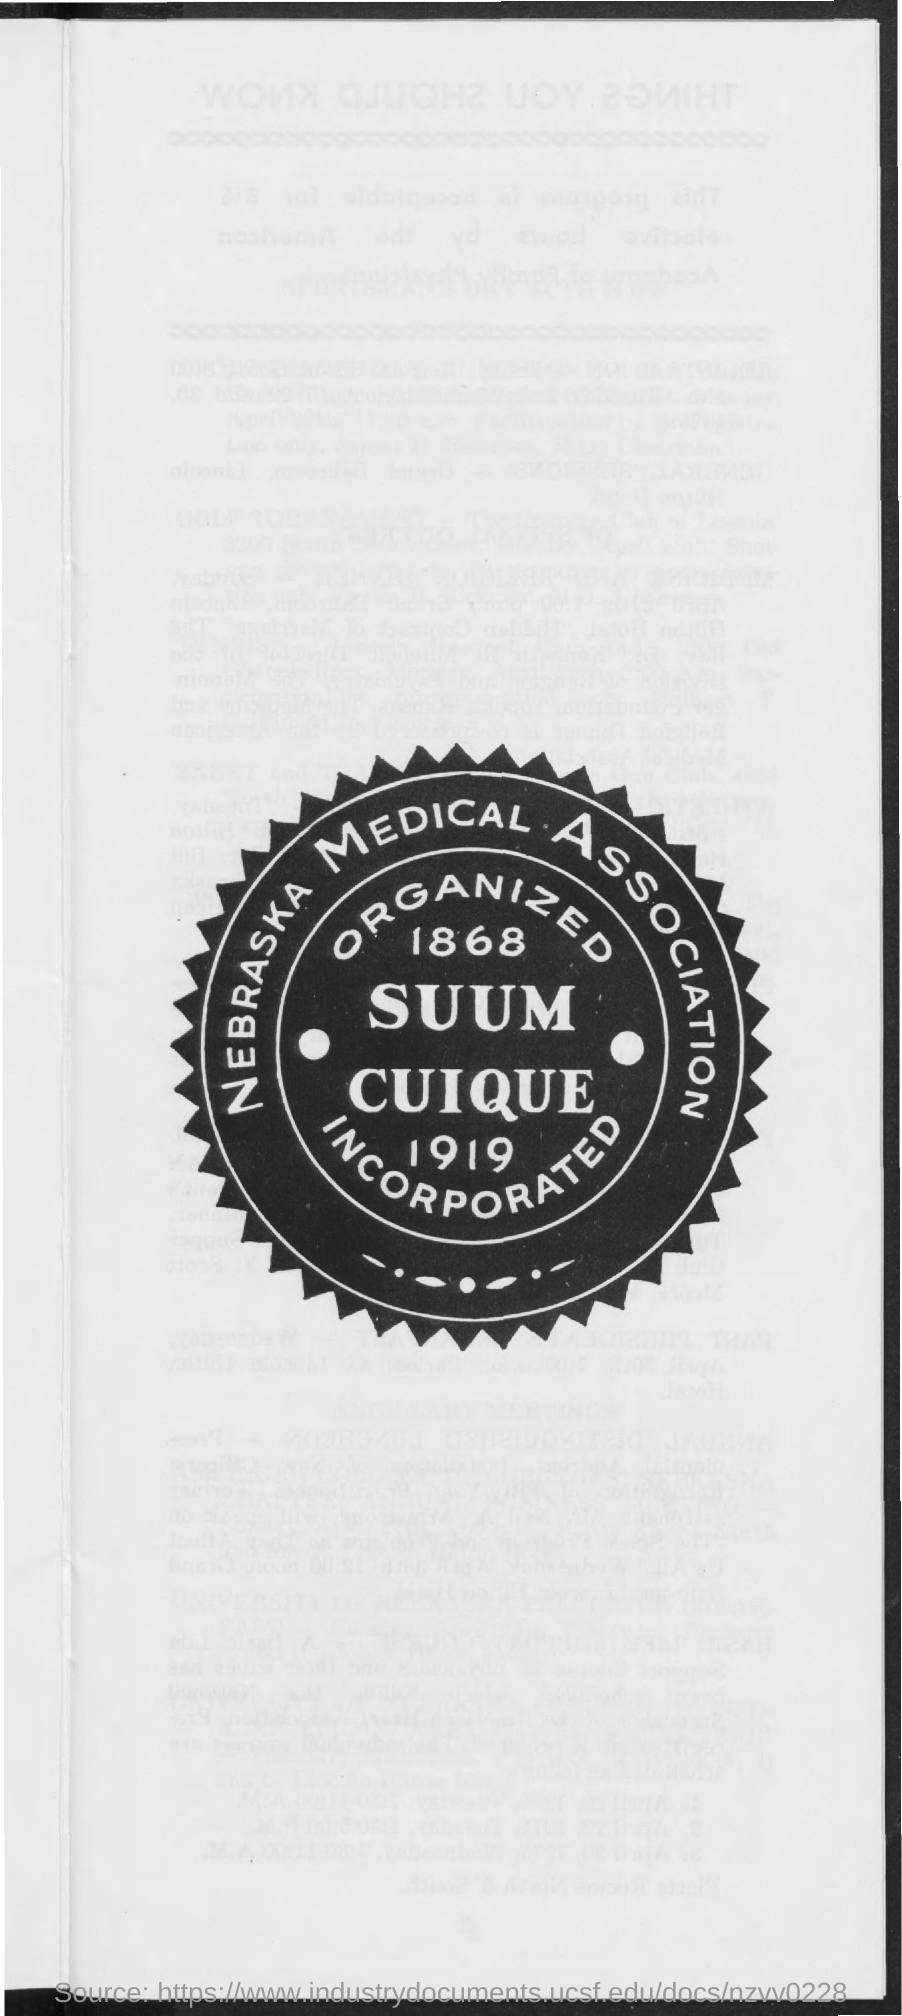Which association is it?
Your answer should be compact. Nebraska medical association. 